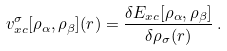Convert formula to latex. <formula><loc_0><loc_0><loc_500><loc_500>v _ { x c } ^ { \sigma } [ \rho _ { \alpha } , \rho _ { \beta } ] ( { r } ) = \frac { \delta E _ { x c } [ \rho _ { \alpha } , \rho _ { \beta } ] } { \delta \rho _ { \sigma } ( { r } ) } \, .</formula> 